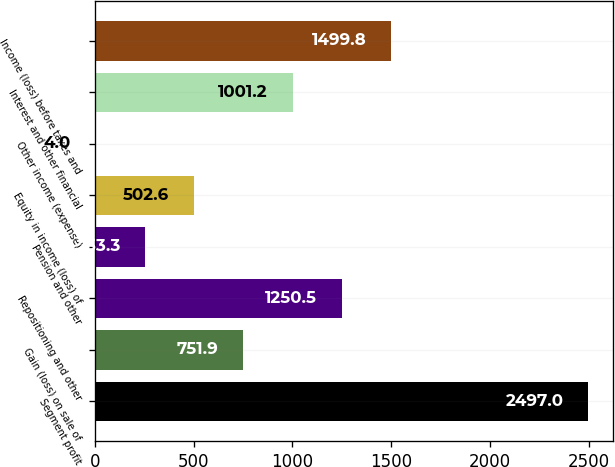<chart> <loc_0><loc_0><loc_500><loc_500><bar_chart><fcel>Segment profit<fcel>Gain (loss) on sale of<fcel>Repositioning and other<fcel>Pension and other<fcel>Equity in income (loss) of<fcel>Other income (expense)<fcel>Interest and other financial<fcel>Income (loss) before taxes and<nl><fcel>2497<fcel>751.9<fcel>1250.5<fcel>253.3<fcel>502.6<fcel>4<fcel>1001.2<fcel>1499.8<nl></chart> 